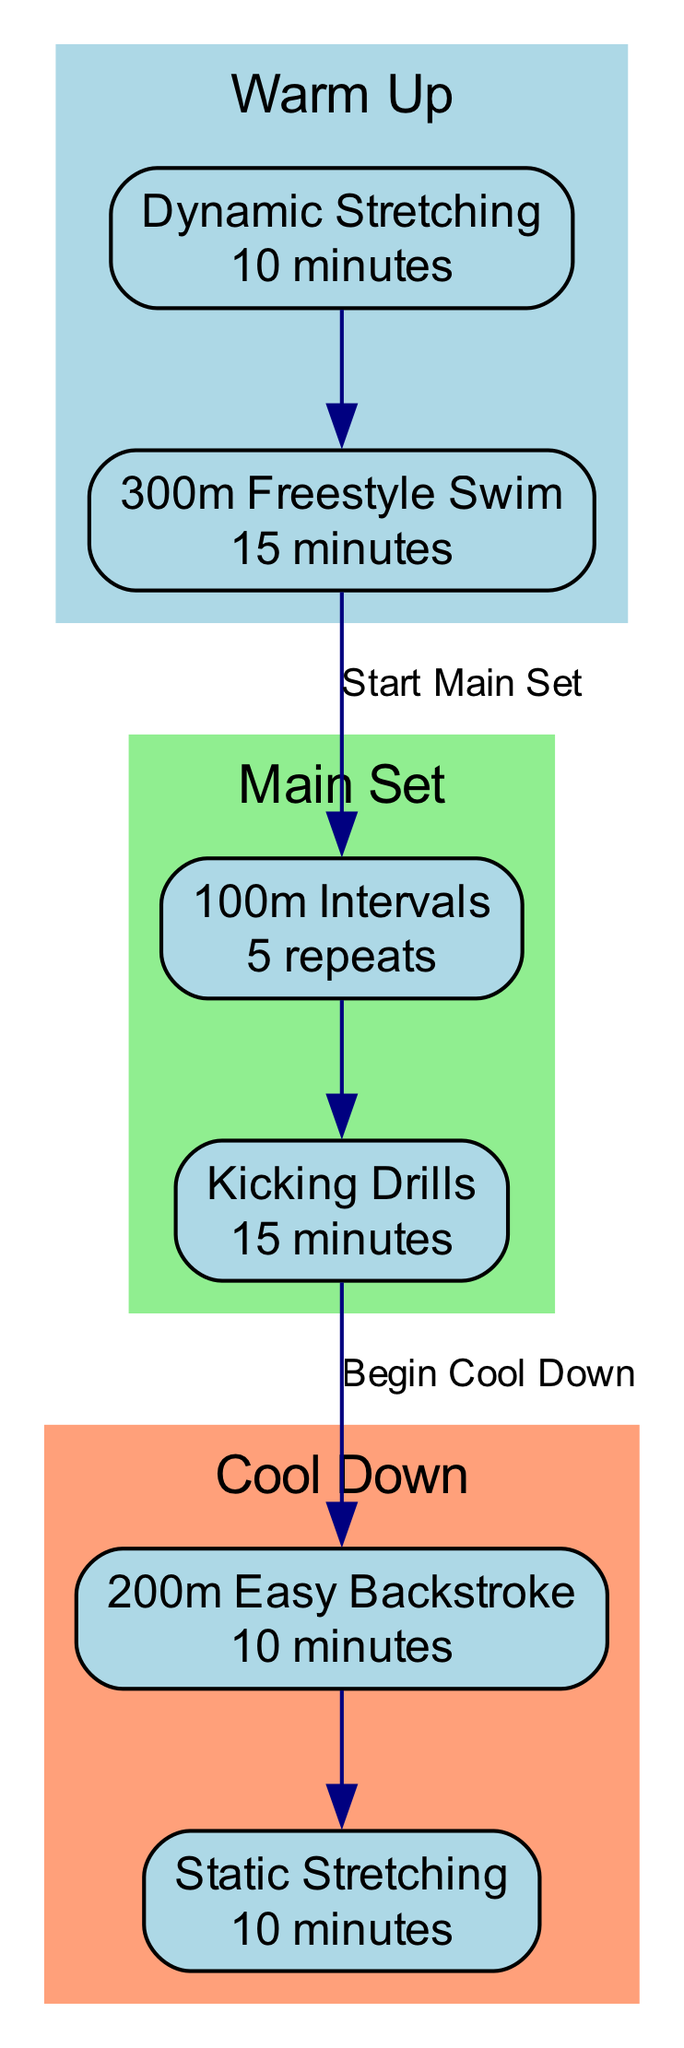What is the duration of Dynamic Stretching? The node for Dynamic Stretching shows the duration as "10 minutes". Therefore, the answer directly corresponds to the duration provided in the diagram.
Answer: 10 minutes How many repeats are there in the 100 Meter Intervals drill? In the node for 100 Meter Intervals, it states "5 repeats". This is a direct reference to the number of times the drill is performed, as indicated in the diagram.
Answer: 5 What is the rest period for the 100 Meter Intervals? The diagram specifies a "30 seconds" rest period next to the 100 Meter Intervals drill. Thus, the answer is based on the specific detail included in that node.
Answer: 30 seconds What is the focus of the Kicking Drills? The Kicking Drills node describes the focus as "kick technique". This phrase directly answers the question about the primary aim of this drill, as indicated in the diagram.
Answer: kick technique What is the total duration of the Cool Down phase? The Cool Down phase contains two drills: 200 Meter Easy Backstroke for "10 minutes" and Static Stretching for "10 minutes". Adding these durations gives a total of 20 minutes for the Cool Down phase. Therefore, the answer must express this combined duration.
Answer: 20 minutes Which drill comes before the Main Set? The last drill in the Warm Up phase, which is "300 Meter Freestyle Swim", is the one that directly precedes the Main Set phase in the flow of the diagram.
Answer: 300 Meter Freestyle Swim How many total drills are in the Main Set? The Main Set contains two distinct drills: 100 Meter Intervals and Kicking Drills. This count of drills is derived from the nodes represented in the Main Set cluster of the diagram.
Answer: 2 What is the main objective of Static Stretching? The description for Static Stretching focuses on "improve flexibility". Hence, it summarizes the primary purpose of this drill as it is presented in the diagram.
Answer: improve flexibility 